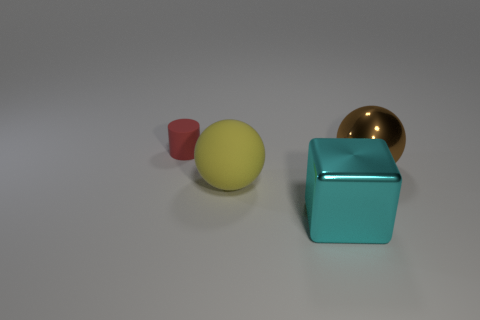Is there anything else that is the same size as the red rubber thing?
Provide a short and direct response. No. What number of objects are both on the left side of the metal sphere and behind the matte sphere?
Give a very brief answer. 1. How many big yellow rubber spheres are behind the yellow sphere?
Provide a short and direct response. 0. Are there any red objects of the same shape as the cyan metallic object?
Offer a very short reply. No. Does the big cyan metallic thing have the same shape as the matte thing that is in front of the small red rubber cylinder?
Keep it short and to the point. No. How many cylinders are either red things or yellow things?
Your answer should be very brief. 1. What is the shape of the matte object that is right of the small rubber cylinder?
Your response must be concise. Sphere. What number of big yellow spheres have the same material as the brown sphere?
Ensure brevity in your answer.  0. Are there fewer big brown balls on the right side of the large brown shiny object than blue metal cylinders?
Provide a short and direct response. No. How big is the red matte thing that is to the left of the rubber thing right of the red matte cylinder?
Ensure brevity in your answer.  Small. 